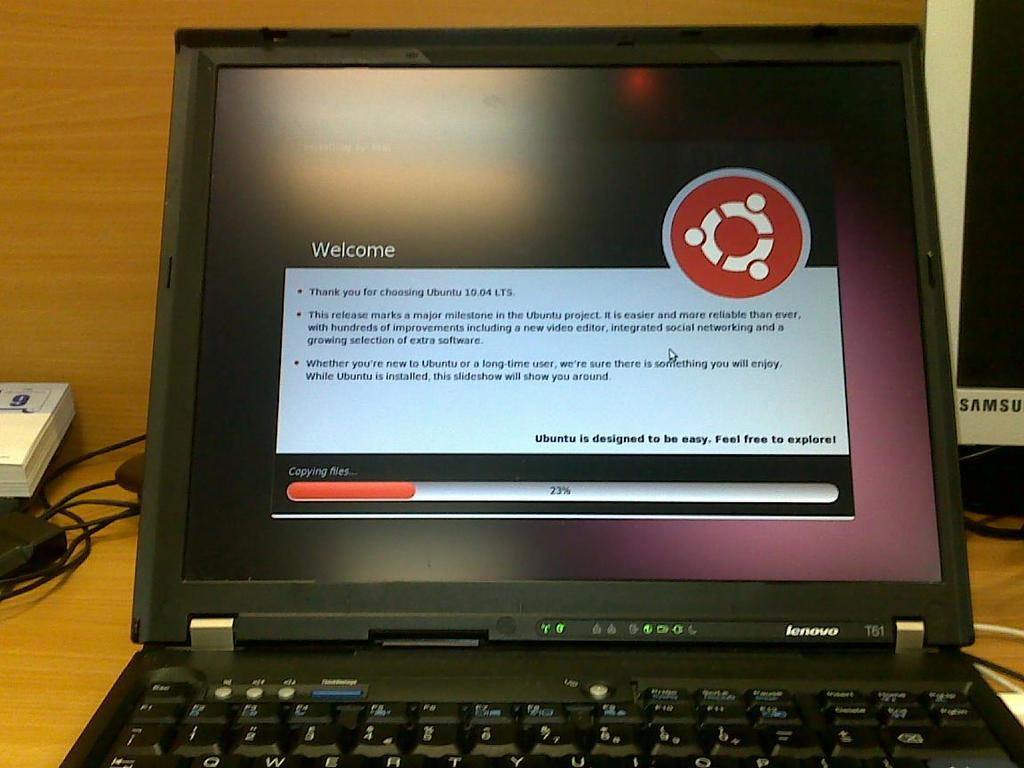<image>
Give a short and clear explanation of the subsequent image. A welcome screen on a laptop displaying a progress bar of 23% 